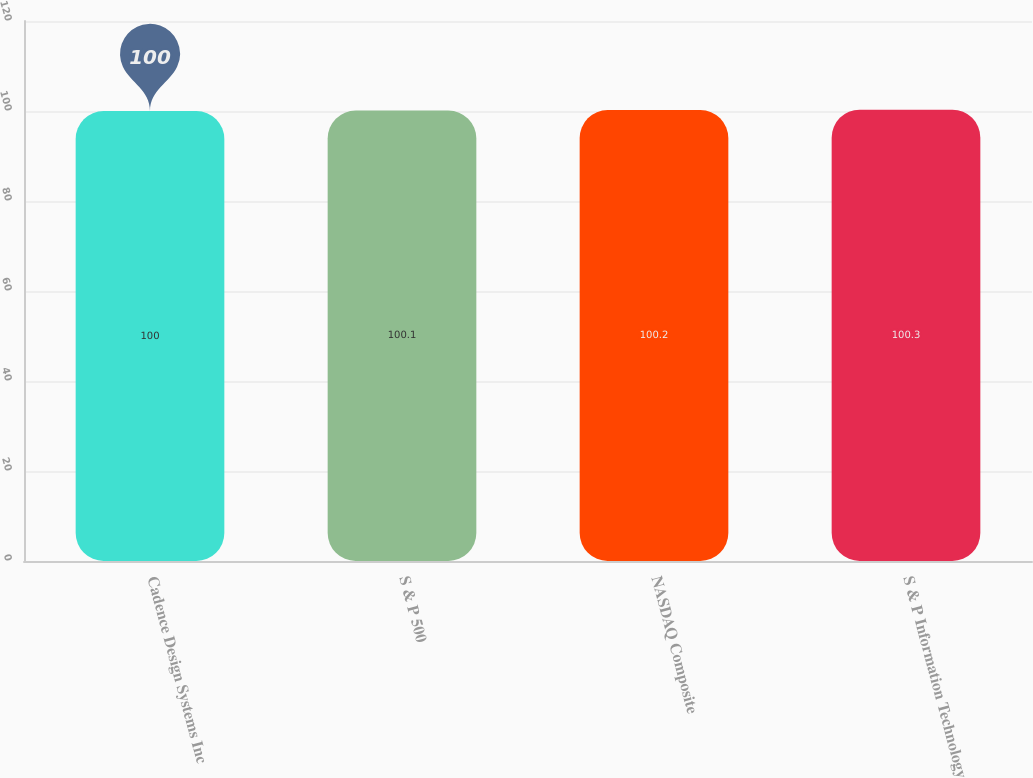Convert chart to OTSL. <chart><loc_0><loc_0><loc_500><loc_500><bar_chart><fcel>Cadence Design Systems Inc<fcel>S & P 500<fcel>NASDAQ Composite<fcel>S & P Information Technology<nl><fcel>100<fcel>100.1<fcel>100.2<fcel>100.3<nl></chart> 